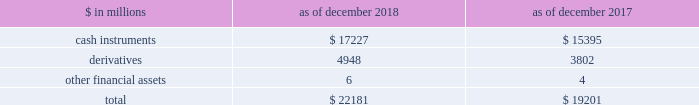The goldman sachs group , inc .
And subsidiaries notes to consolidated financial statements the table below presents a summary of level 3 financial assets. .
Level 3 financial assets as of december 2018 increased compared with december 2017 , primarily reflecting an increase in level 3 cash instruments .
See notes 6 through 8 for further information about level 3 financial assets ( including information about unrealized gains and losses related to level 3 financial assets and financial liabilities , and transfers in and out of level 3 ) .
Note 6 .
Cash instruments cash instruments include u.s .
Government and agency obligations , non-u.s .
Government and agency obligations , mortgage-backed loans and securities , corporate debt instruments , equity securities , investments in funds at nav , and other non-derivative financial instruments owned and financial instruments sold , but not yet purchased .
See below for the types of cash instruments included in each level of the fair value hierarchy and the valuation techniques and significant inputs used to determine their fair values .
See note 5 for an overview of the firm 2019s fair value measurement policies .
Level 1 cash instruments level 1 cash instruments include certain money market instruments , u.s .
Government obligations , most non-u.s .
Government obligations , certain government agency obligations , certain corporate debt instruments and actively traded listed equities .
These instruments are valued using quoted prices for identical unrestricted instruments in active markets .
The firm defines active markets for equity instruments based on the average daily trading volume both in absolute terms and relative to the market capitalization for the instrument .
The firm defines active markets for debt instruments based on both the average daily trading volume and the number of days with trading activity .
Level 2 cash instruments level 2 cash instruments include most money market instruments , most government agency obligations , certain non-u.s .
Government obligations , most mortgage-backed loans and securities , most corporate debt instruments , most state and municipal obligations , most other debt obligations , restricted or less liquid listed equities , commodities and certain lending commitments .
Valuations of level 2 cash instruments can be verified to quoted prices , recent trading activity for identical or similar instruments , broker or dealer quotations or alternative pricing sources with reasonable levels of price transparency .
Consideration is given to the nature of the quotations ( e.g. , indicative or firm ) and the relationship of recent market activity to the prices provided from alternative pricing sources .
Valuation adjustments are typically made to level 2 cash instruments ( i ) if the cash instrument is subject to transfer restrictions and/or ( ii ) for other premiums and liquidity discounts that a market participant would require to arrive at fair value .
Valuation adjustments are generally based on market evidence .
Level 3 cash instruments level 3 cash instruments have one or more significant valuation inputs that are not observable .
Absent evidence to the contrary , level 3 cash instruments are initially valued at transaction price , which is considered to be the best initial estimate of fair value .
Subsequently , the firm uses other methodologies to determine fair value , which vary based on the type of instrument .
Valuation inputs and assumptions are changed when corroborated by substantive observable evidence , including values realized on sales .
Valuation techniques and significant inputs of level 3 cash instruments valuation techniques of level 3 cash instruments vary by instrument , but are generally based on discounted cash flow techniques .
The valuation techniques and the nature of significant inputs used to determine the fair values of each type of level 3 cash instrument are described below : loans and securities backed by commercial real estate .
Loans and securities backed by commercial real estate are directly or indirectly collateralized by a single commercial real estate property or a portfolio of properties , and may include tranches of varying levels of subordination .
Significant inputs are generally determined based on relative value analyses and include : 2030 market yields implied by transactions of similar or related assets and/or current levels and changes in market indices such as the cmbx ( an index that tracks the performance of commercial mortgage bonds ) ; 118 goldman sachs 2018 form 10-k .
For level 3 financial assets in millions , for 2018 and 2017 , what was the largest balance of derivatives? 
Computations: table_max(derivatives, none)
Answer: 4948.0. 